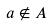Convert formula to latex. <formula><loc_0><loc_0><loc_500><loc_500>a \notin A</formula> 